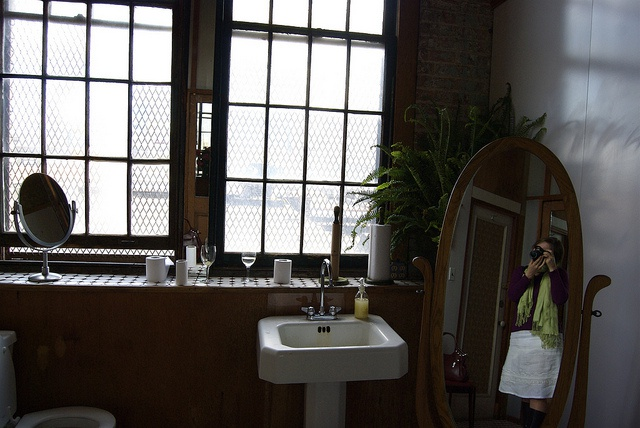Describe the objects in this image and their specific colors. I can see potted plant in black, lightgray, gray, and darkgray tones, people in black, gray, and darkgreen tones, sink in black, gray, and darkgray tones, toilet in black and purple tones, and handbag in black and gray tones in this image. 